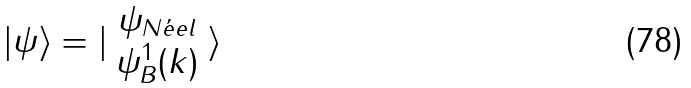Convert formula to latex. <formula><loc_0><loc_0><loc_500><loc_500>| \psi \rangle = | \begin{array} { c } \psi _ { N \acute { e } e l } \\ \psi _ { B } ^ { 1 } ( k ) \end{array} \rangle</formula> 